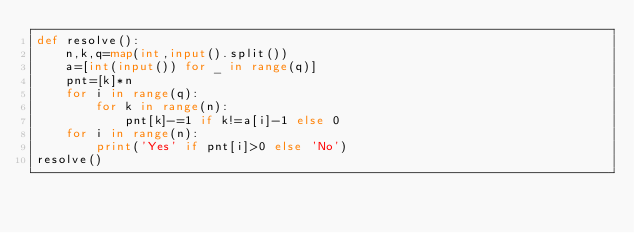Convert code to text. <code><loc_0><loc_0><loc_500><loc_500><_Python_>def resolve():
    n,k,q=map(int,input().split())
    a=[int(input()) for _ in range(q)]
    pnt=[k]*n
    for i in range(q):
        for k in range(n):
            pnt[k]-=1 if k!=a[i]-1 else 0
    for i in range(n):
        print('Yes' if pnt[i]>0 else 'No')
resolve()</code> 